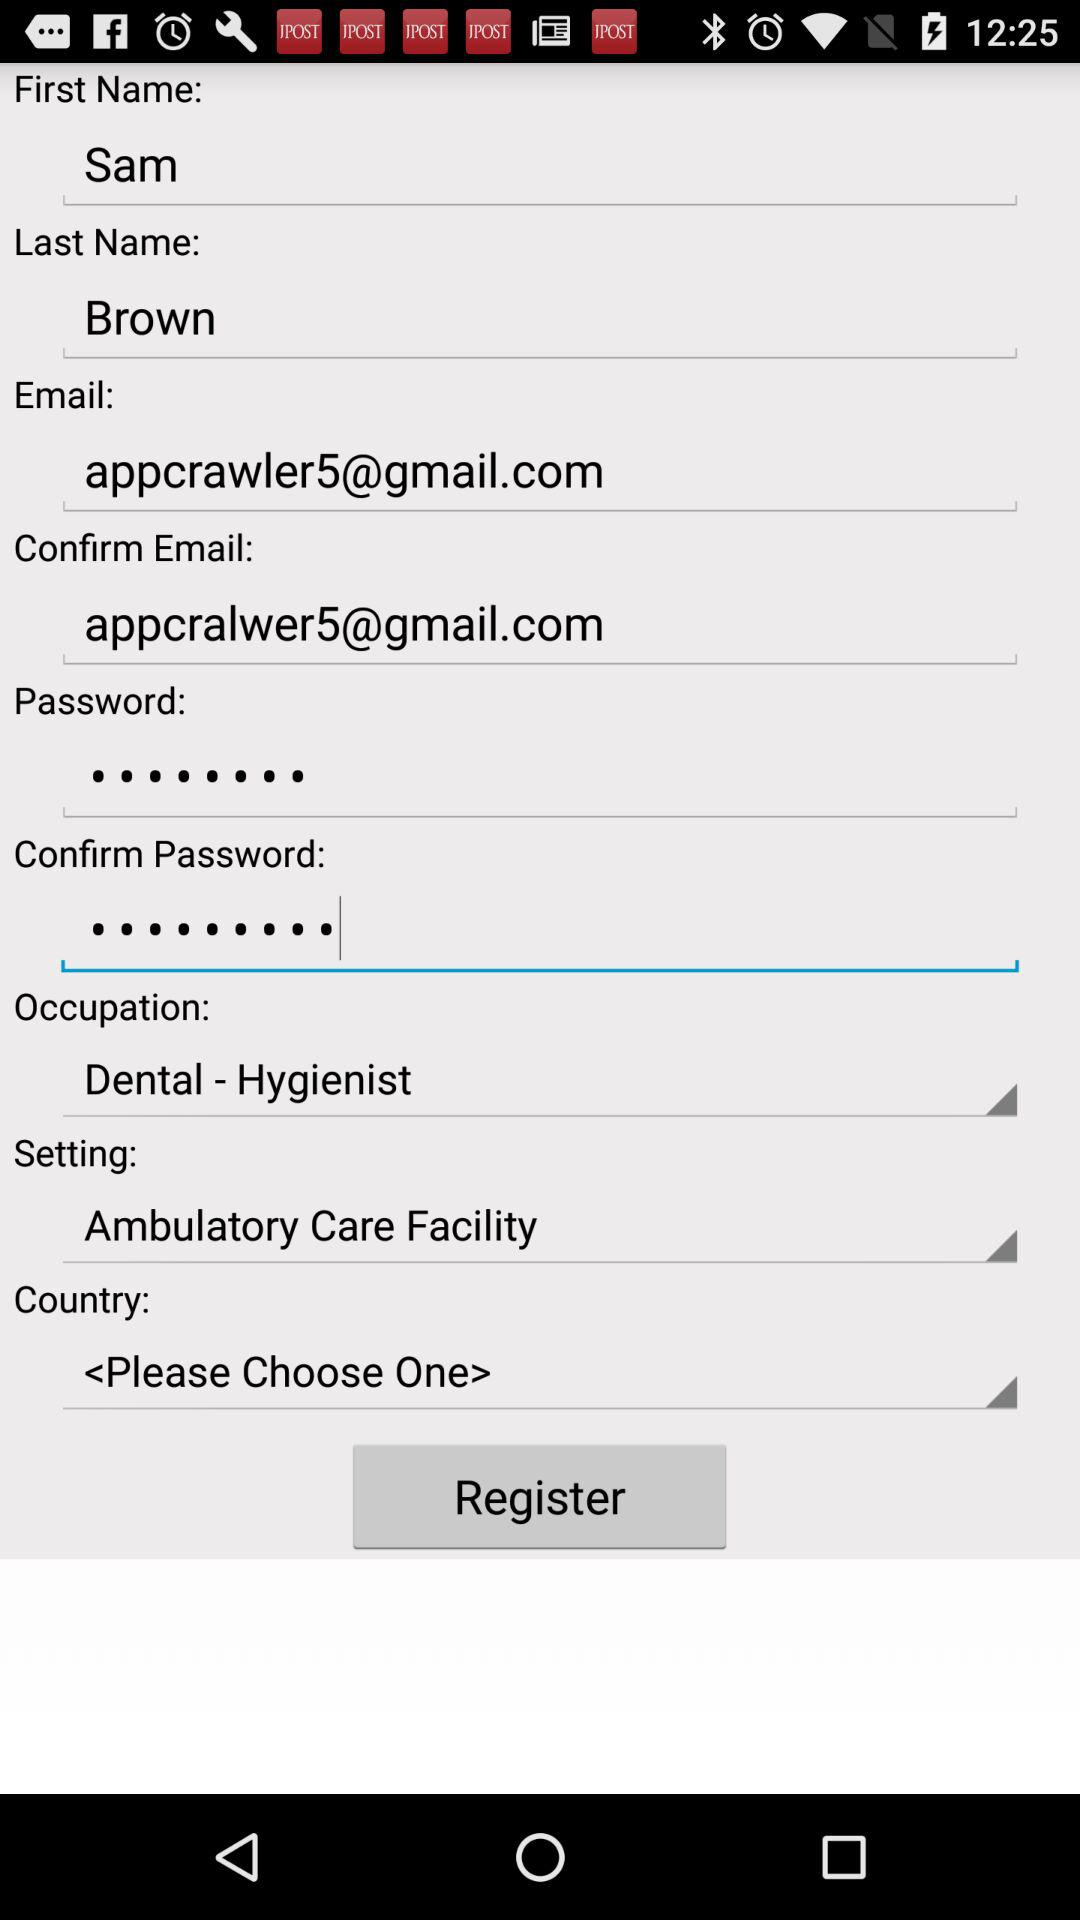What is the last name? The last name is Brown. 